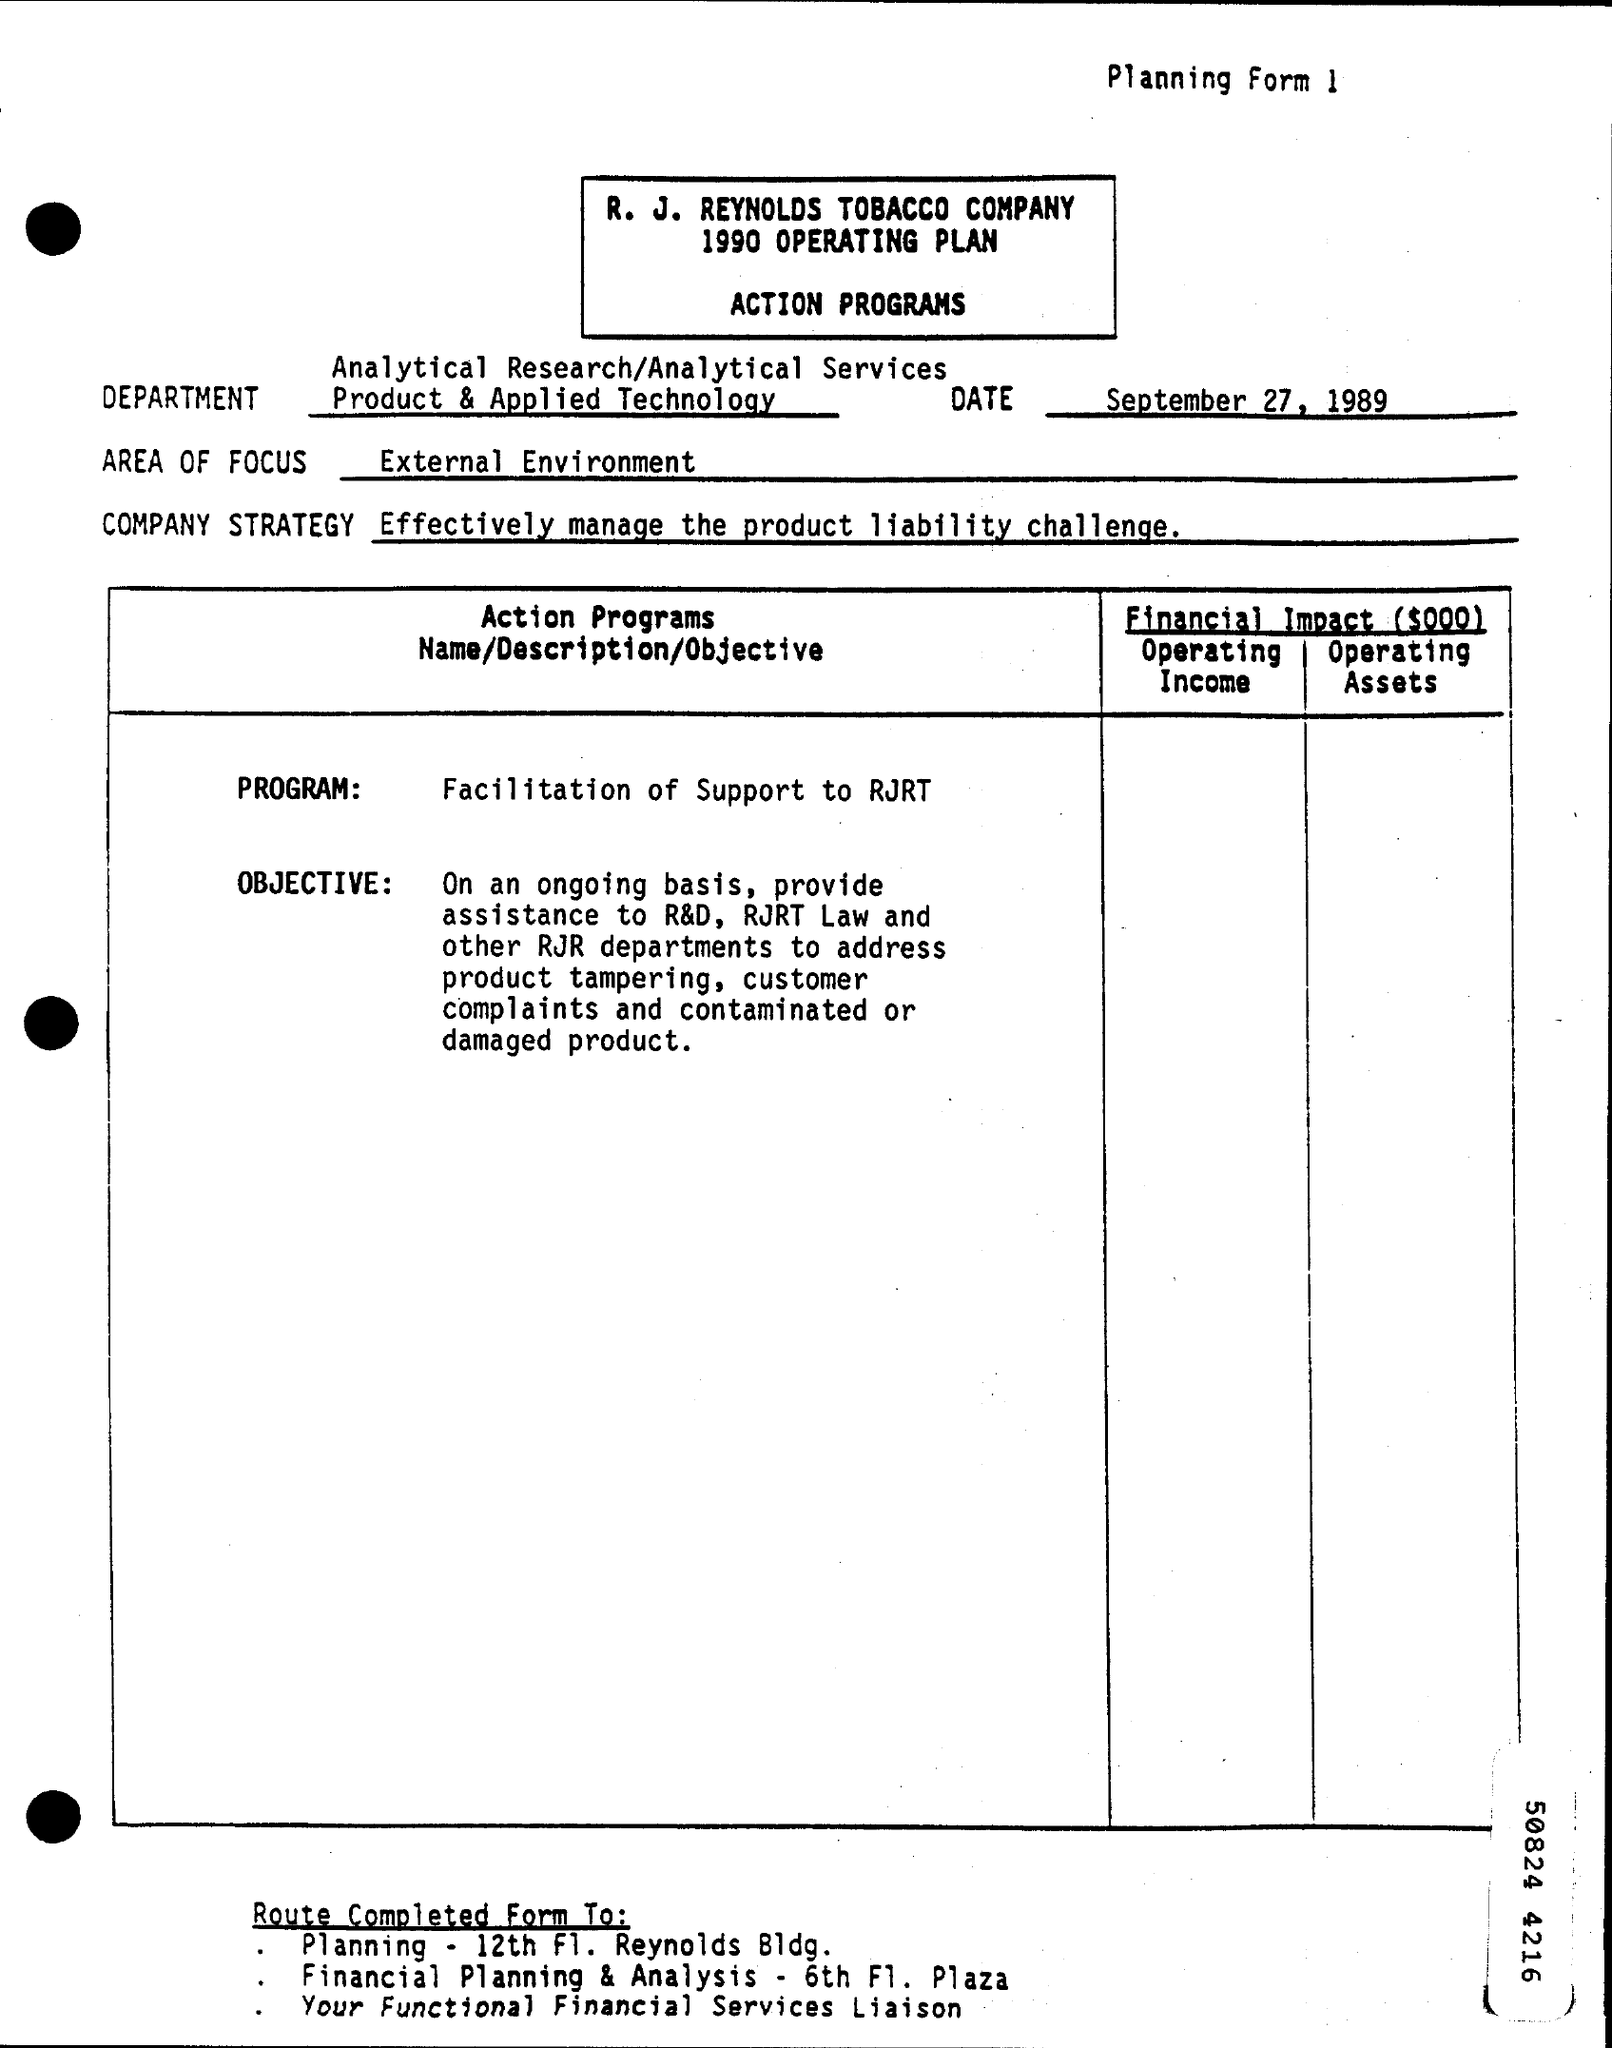What is the Area of Focus mentioned in the Planning form?
Offer a very short reply. External environment. What is the Company Strategy mentioned in the planning form?
Give a very brief answer. Effectively manage the product liability challenge. What is the action program name given in the planning form?
Provide a succinct answer. Facilitation of Support to RJRT. What is the date mentioned in the Planning form?
Keep it short and to the point. September 27, 1989. 